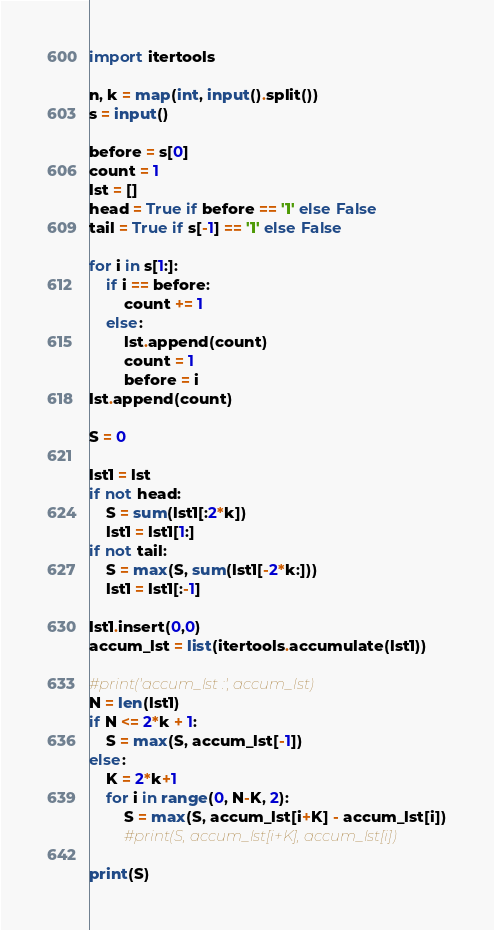Convert code to text. <code><loc_0><loc_0><loc_500><loc_500><_Python_>import itertools

n, k = map(int, input().split())
s = input()

before = s[0]
count = 1
lst = []
head = True if before == '1' else False
tail = True if s[-1] == '1' else False

for i in s[1:]:
    if i == before:
        count += 1
    else:
        lst.append(count)
        count = 1
        before = i
lst.append(count)

S = 0

lst1 = lst
if not head:
    S = sum(lst1[:2*k])
    lst1 = lst1[1:]
if not tail:
    S = max(S, sum(lst1[-2*k:]))
    lst1 = lst1[:-1]

lst1.insert(0,0)
accum_lst = list(itertools.accumulate(lst1))

#print('accum_lst :', accum_lst)
N = len(lst1)
if N <= 2*k + 1:
    S = max(S, accum_lst[-1])
else:
    K = 2*k+1
    for i in range(0, N-K, 2):
        S = max(S, accum_lst[i+K] - accum_lst[i])
        #print(S, accum_lst[i+K], accum_lst[i])

print(S)</code> 